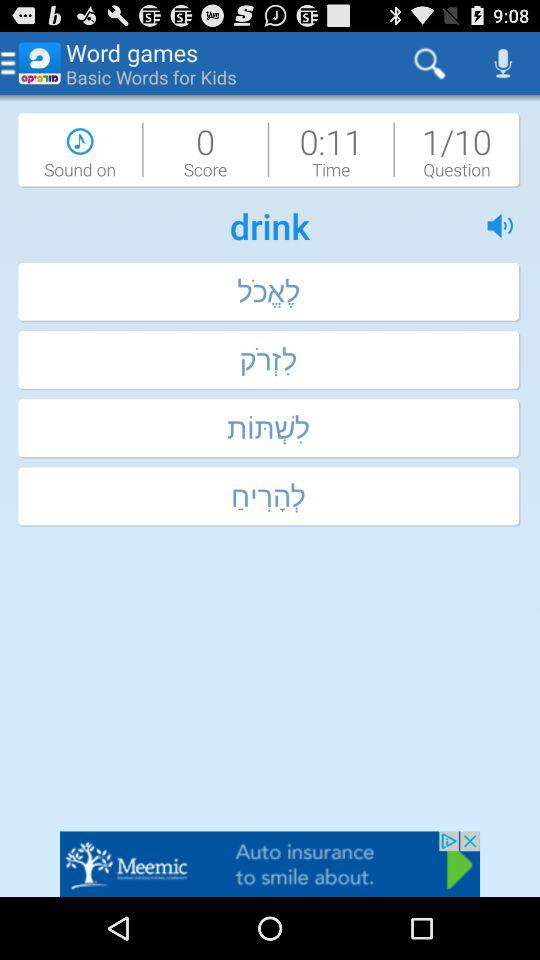What is the score? The score is 0. 